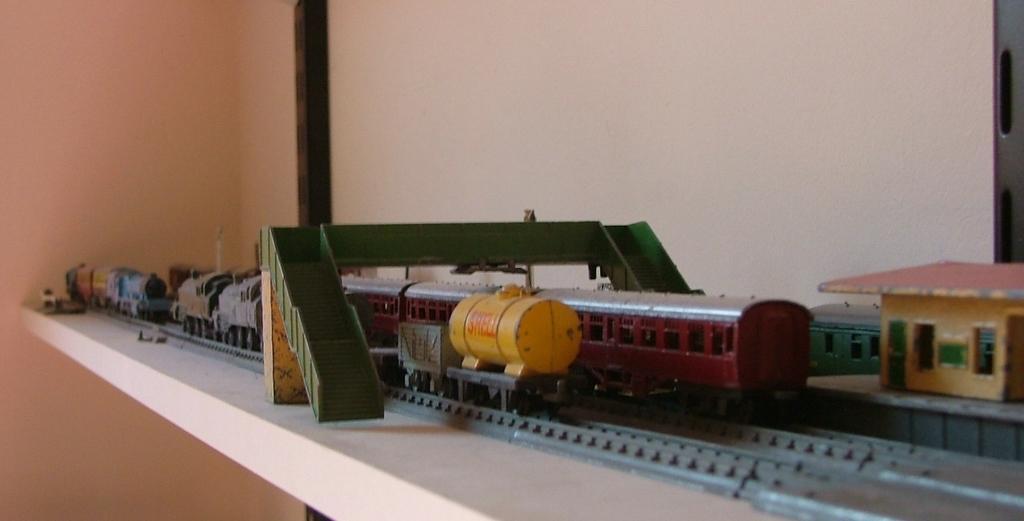Describe this image in one or two sentences. In this image there is a shelf on that shelf there is a model of a train tracks and trains and a bridge. 